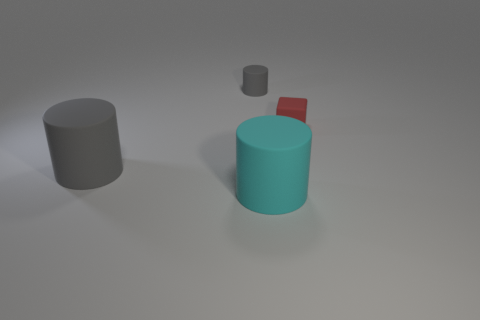The red rubber block is what size?
Offer a very short reply. Small. Is the number of small red rubber objects less than the number of matte objects?
Provide a short and direct response. Yes. How many big rubber things are the same color as the small rubber cylinder?
Ensure brevity in your answer.  1. There is a big matte thing that is on the left side of the cyan rubber object; does it have the same color as the small cylinder?
Ensure brevity in your answer.  Yes. What shape is the tiny object that is to the left of the tiny red block?
Your answer should be compact. Cylinder. Is there a tiny gray rubber cylinder that is left of the large rubber cylinder behind the large cyan cylinder?
Offer a very short reply. No. What number of large gray cylinders are made of the same material as the big cyan thing?
Your answer should be very brief. 1. There is a rubber cylinder in front of the big cylinder on the left side of the cylinder behind the rubber cube; what size is it?
Ensure brevity in your answer.  Large. How many big gray matte cylinders are to the left of the large cyan thing?
Provide a short and direct response. 1. Is the number of big cyan rubber things greater than the number of large metallic cylinders?
Provide a succinct answer. Yes. 